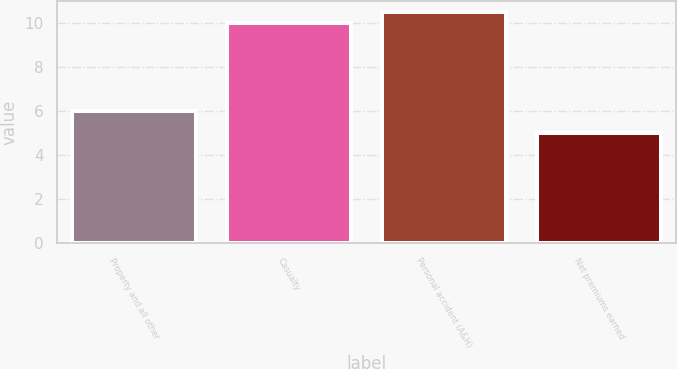Convert chart. <chart><loc_0><loc_0><loc_500><loc_500><bar_chart><fcel>Property and all other<fcel>Casualty<fcel>Personal accident (A&H)<fcel>Net premiums earned<nl><fcel>6<fcel>10<fcel>10.5<fcel>5<nl></chart> 